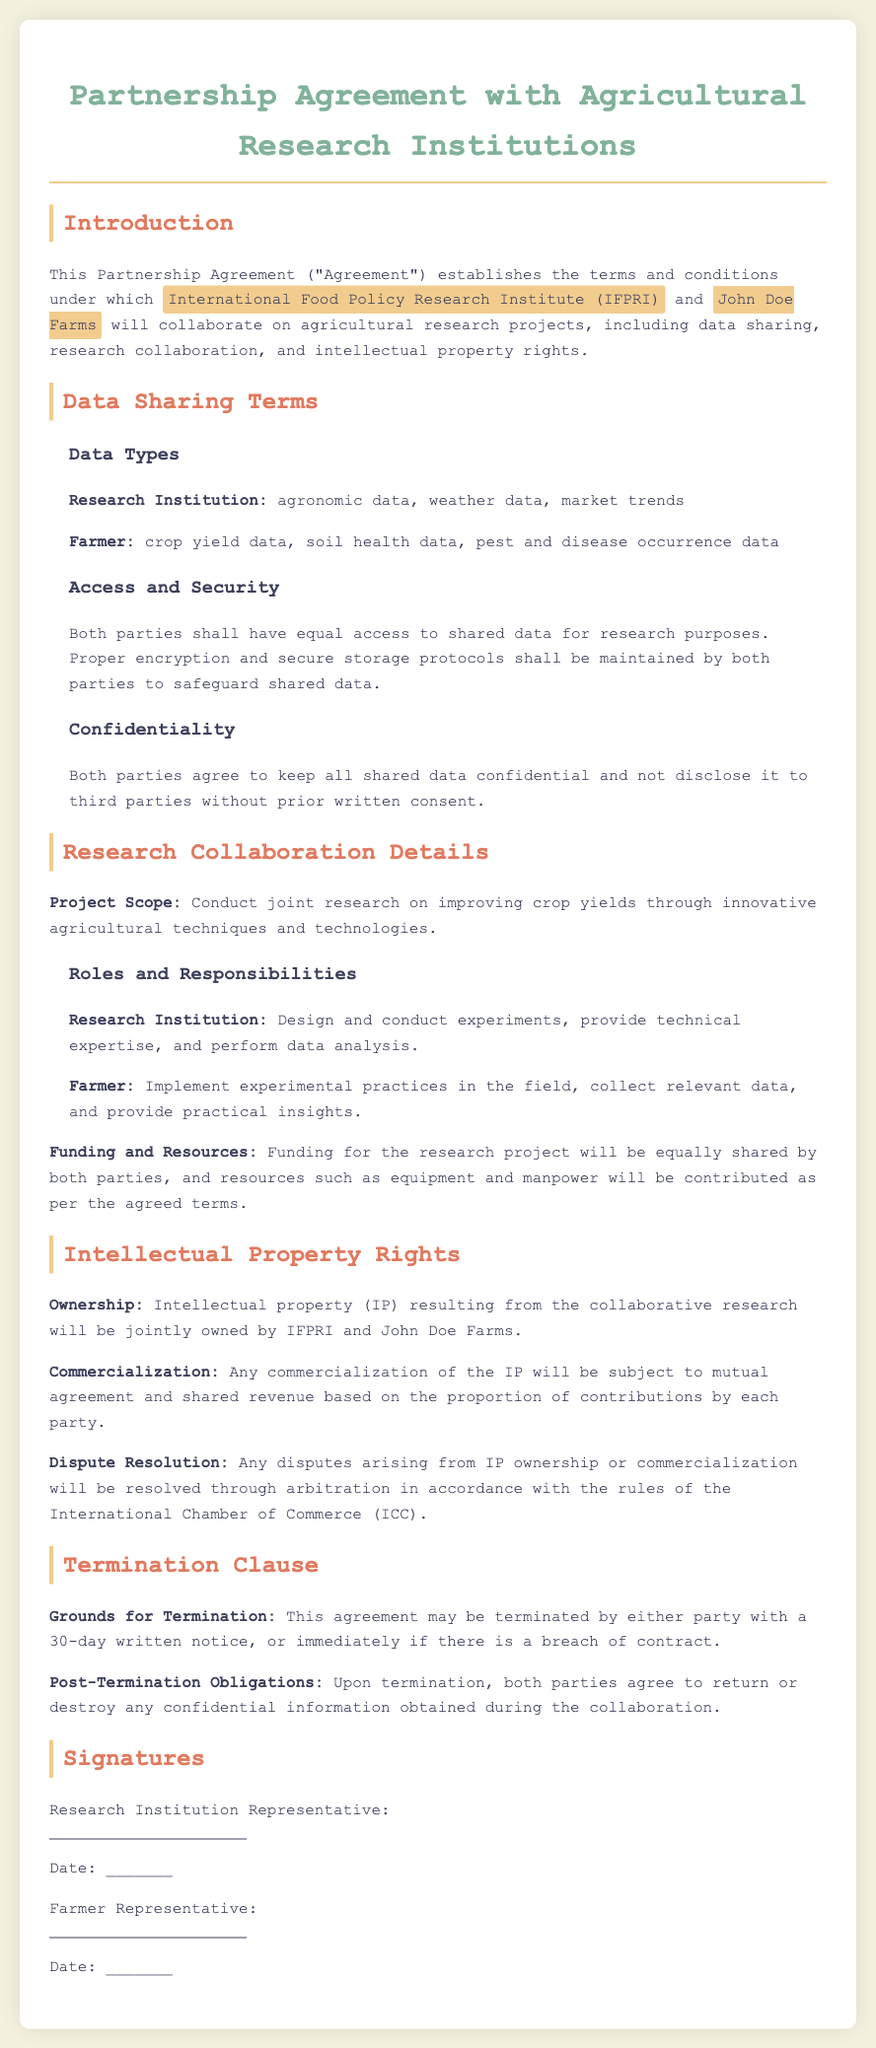What is the name of the research institution involved? The document identifies the research institution as the International Food Policy Research Institute (IFPRI).
Answer: International Food Policy Research Institute (IFPRI) What types of data will the farmer provide? The document specifies that the farmer will provide crop yield data, soil health data, and pest and disease occurrence data.
Answer: crop yield data, soil health data, pest and disease occurrence data What is the duration of the notice required for termination? The document states that either party may terminate the agreement with a 30-day written notice.
Answer: 30-day Who is responsible for conducting experiments according to the agreement? The responsibilities are outlined in the document, stating that the research institution is responsible for designing and conducting experiments.
Answer: Research Institution What will happen to confidential information upon termination? The document specifies that both parties agree to return or destroy any confidential information obtained during the collaboration after termination.
Answer: return or destroy How will the intellectual property be shared after the project? According to the document, intellectual property resulting from the research will be jointly owned by both parties.
Answer: jointly owned 